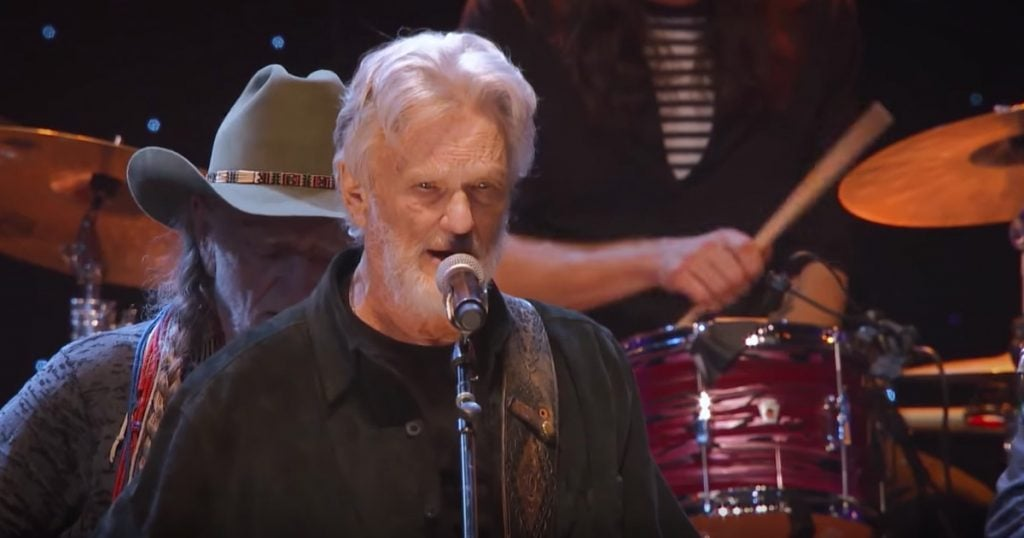Describe a realistic long response scenario reflecting a typical performance of the musicians in the image. In a typical performance, the musicians might be playing at a well-known music festival dedicated to country and folk music. The stage is set against a picturesque backdrop of rolling hills and open skies, providing a perfect setting for their soulful performance. The crowd is a diverse mix of families, young adults, and older fans who have grown up with the genre. The musicians skillfully play their setlist featuring classic hits and new songs, creating an intimate and heartfelt connection with the audience. The singer's voice resonates with passion and authenticity, and the instrumental harmonies create a rich, full soundscape. Between songs, they share stories and anecdotes, further endearing themselves to the audience. As the sun sets, the stage lights cast a warm glow, and the performance concludes with a rousing encore that leaves the audience buzzing with appreciation. 